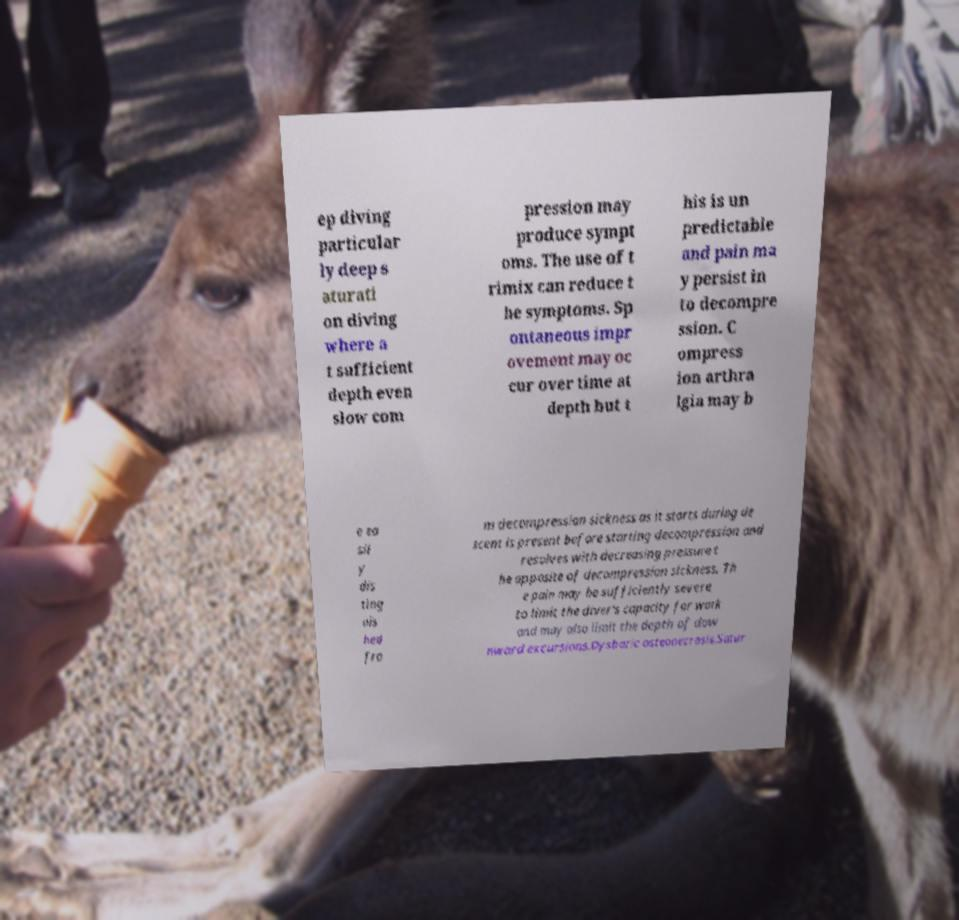Could you assist in decoding the text presented in this image and type it out clearly? ep diving particular ly deep s aturati on diving where a t sufficient depth even slow com pression may produce sympt oms. The use of t rimix can reduce t he symptoms. Sp ontaneous impr ovement may oc cur over time at depth but t his is un predictable and pain ma y persist in to decompre ssion. C ompress ion arthra lgia may b e ea sil y dis ting uis hed fro m decompression sickness as it starts during de scent is present before starting decompression and resolves with decreasing pressure t he opposite of decompression sickness. Th e pain may be sufficiently severe to limit the diver's capacity for work and may also limit the depth of dow nward excursions.Dysbaric osteonecrosis.Satur 